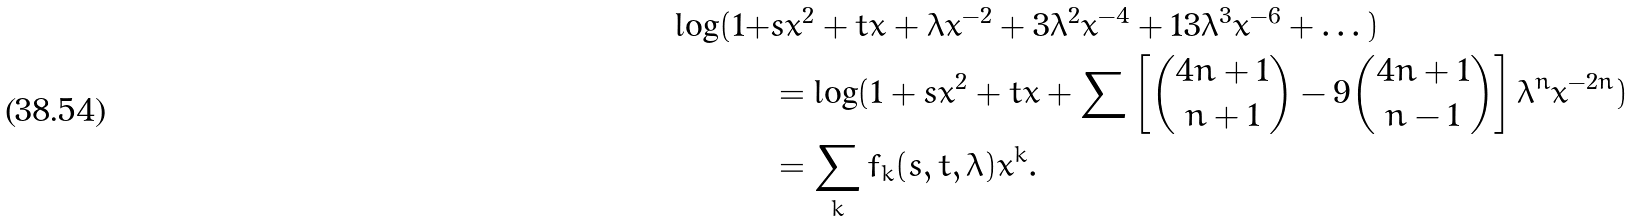<formula> <loc_0><loc_0><loc_500><loc_500>\log ( 1 + & s x ^ { 2 } + t x + \lambda x ^ { - 2 } + 3 \lambda ^ { 2 } x ^ { - 4 } + 1 3 \lambda ^ { 3 } x ^ { - 6 } + \dots ) \\ & = \log ( 1 + s x ^ { 2 } + t x + \sum \left [ \binom { 4 n + 1 } { n + 1 } - 9 \binom { 4 n + 1 } { n - 1 } \right ] \lambda ^ { n } x ^ { - 2 n } ) \\ & = \sum _ { k } \bar { f } _ { k } ( s , t , \lambda ) x ^ { k } .</formula> 